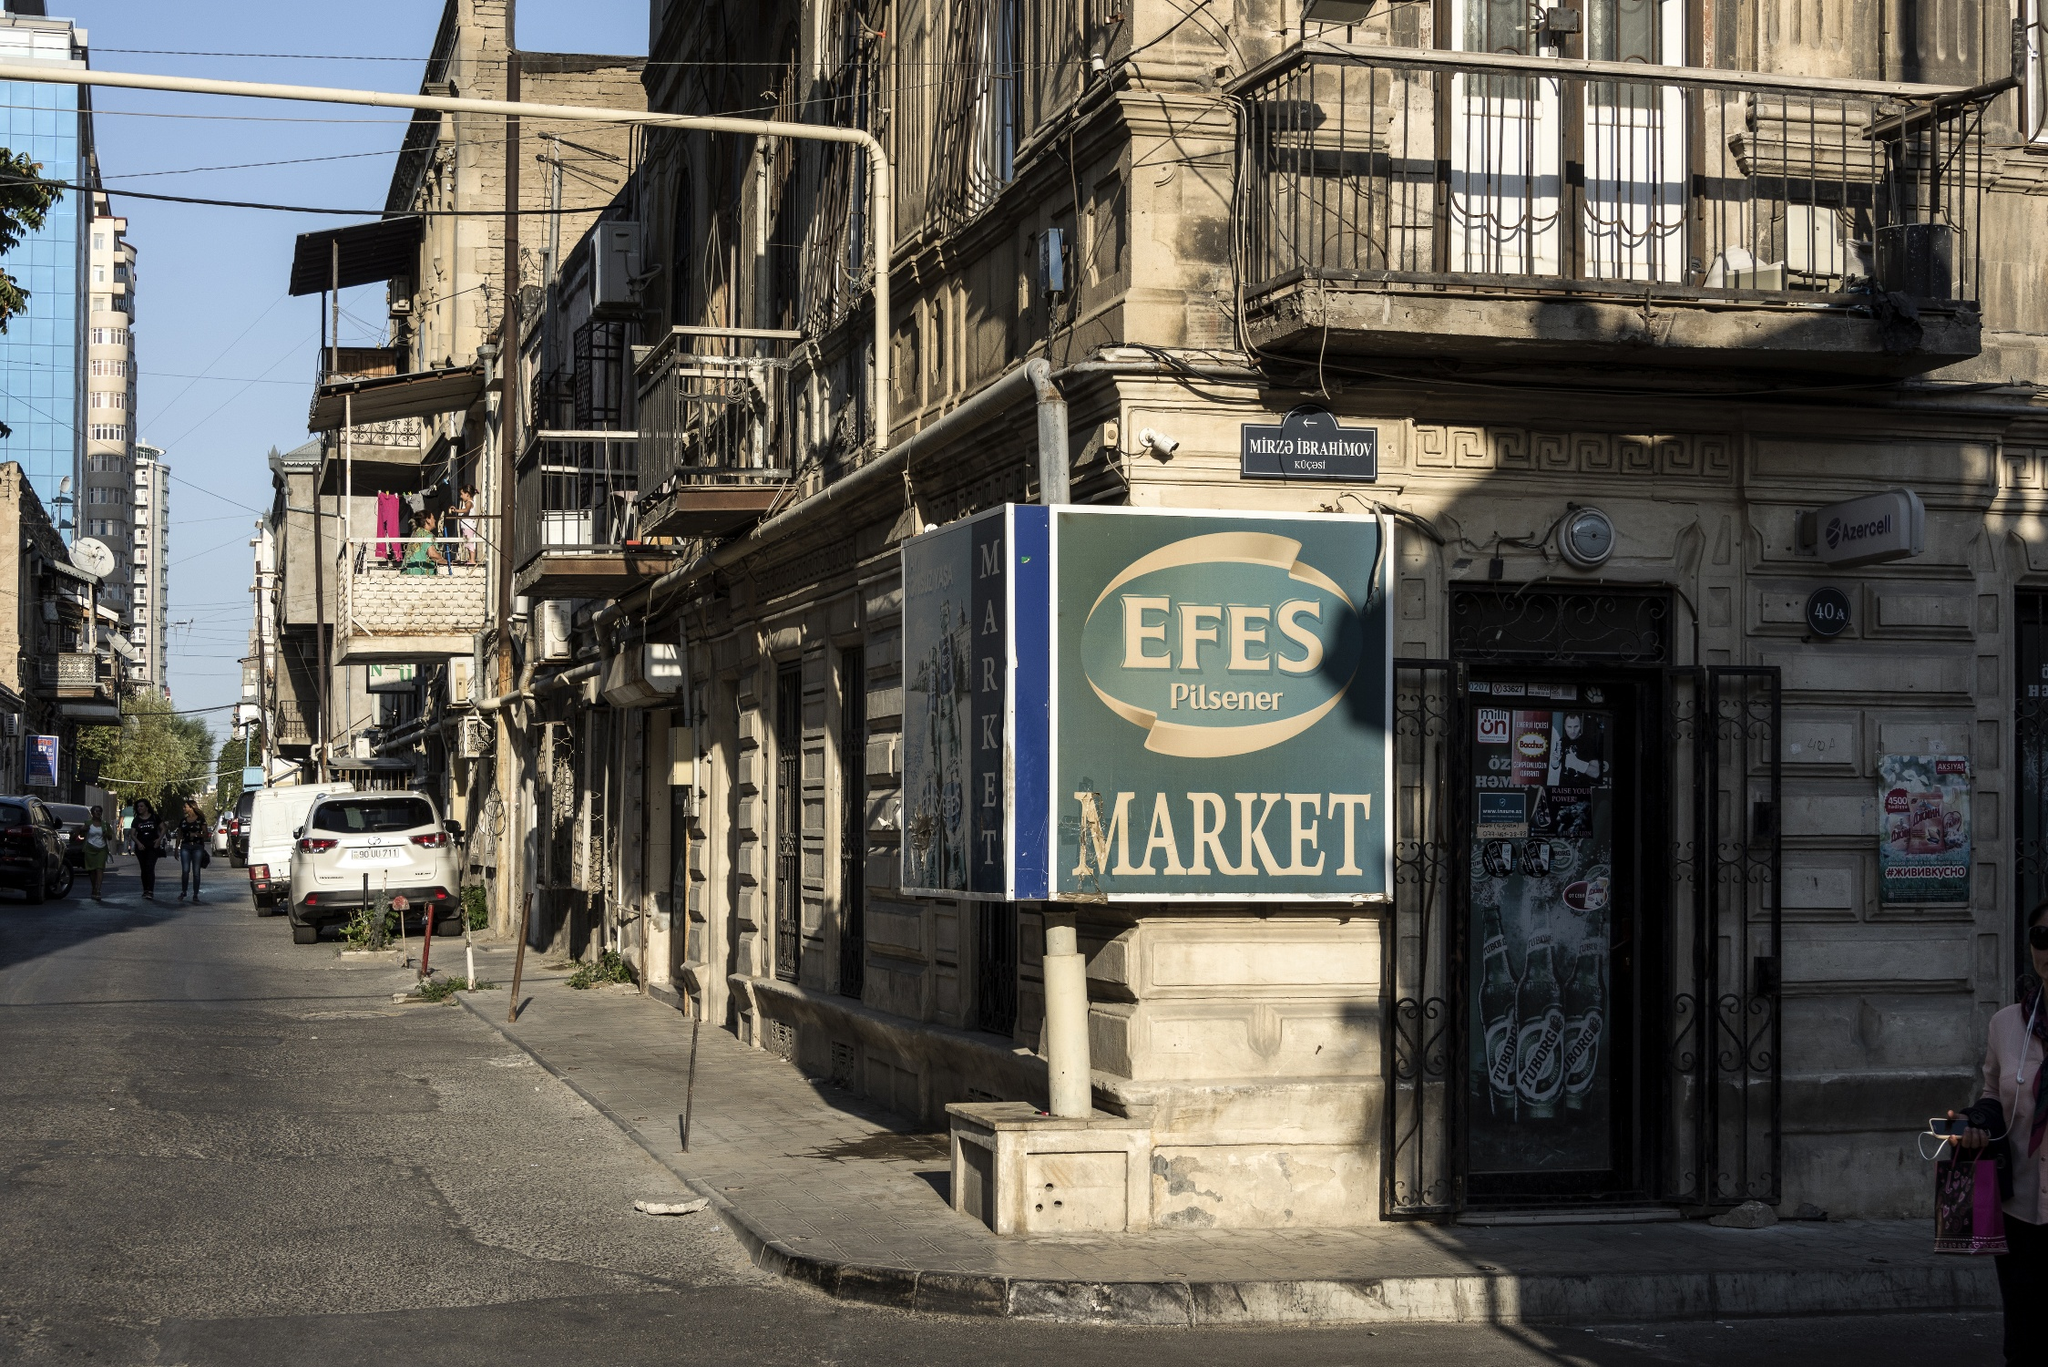Write a detailed description of the given image. The image captures a lively street corner in Istanbul, Turkey. Dominating the scene is a market with a sign reading "EFES Pilsener MARKET", prominently displayed against a weathered building. The building, showing signs of age and wear, is adorned with charming balconies and character-filled windows. Below, the street buzzes with activity, lined with parked cars hinting at the area's popularity. Overhead, an intricate web of power lines crisscrosses the sky, a common sight in bustling urban landscapes. The perspective of the image, taken from a low angle, draws the viewer’s gaze upwards, emphasizing both the height of the building and the market sign. The muted colors in the image echo the urban setting and the weathered facade, adding depth to the scene. Despite the bustling nature, there's an underlying sense of everyday life, capturing a snapshot of a city that never slows down. 